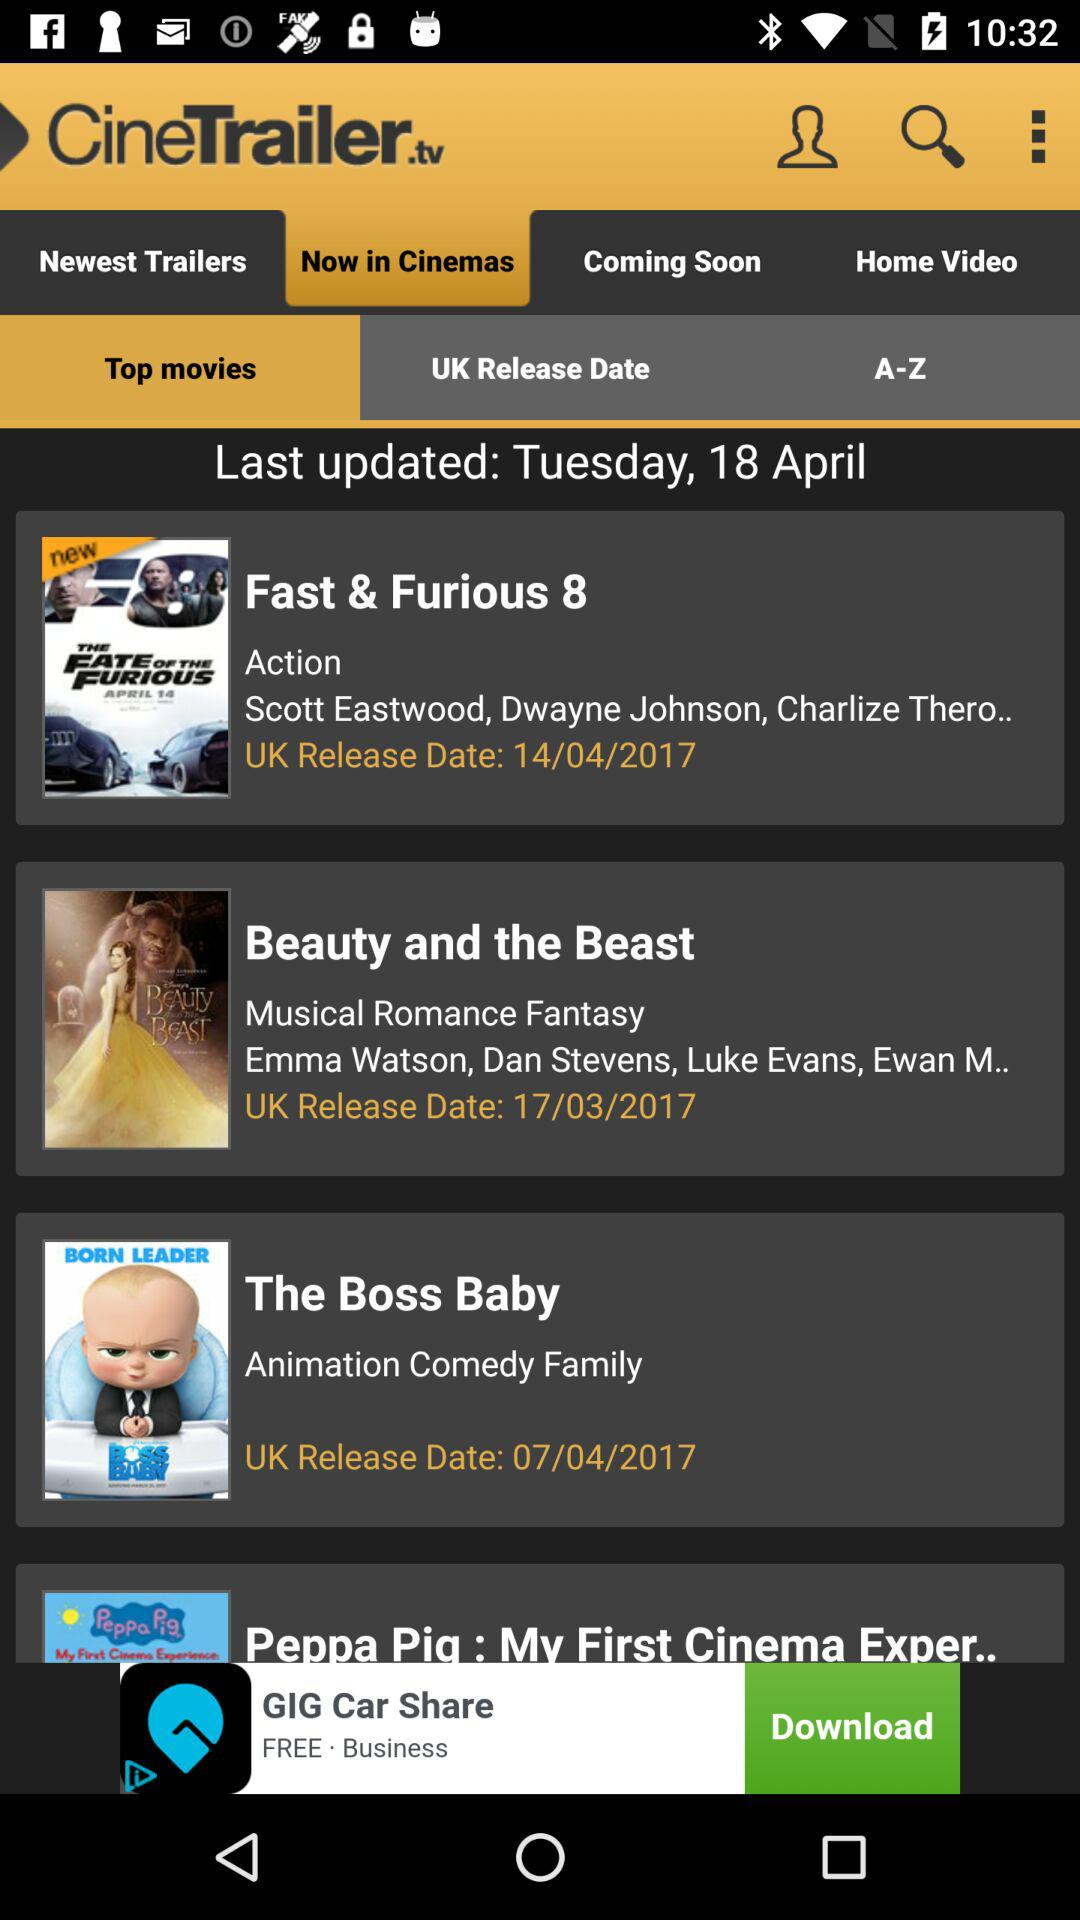What is the release date of "Beauty and the Beast"? The release date of "Beauty and the Beast" is March 17, 2017. 